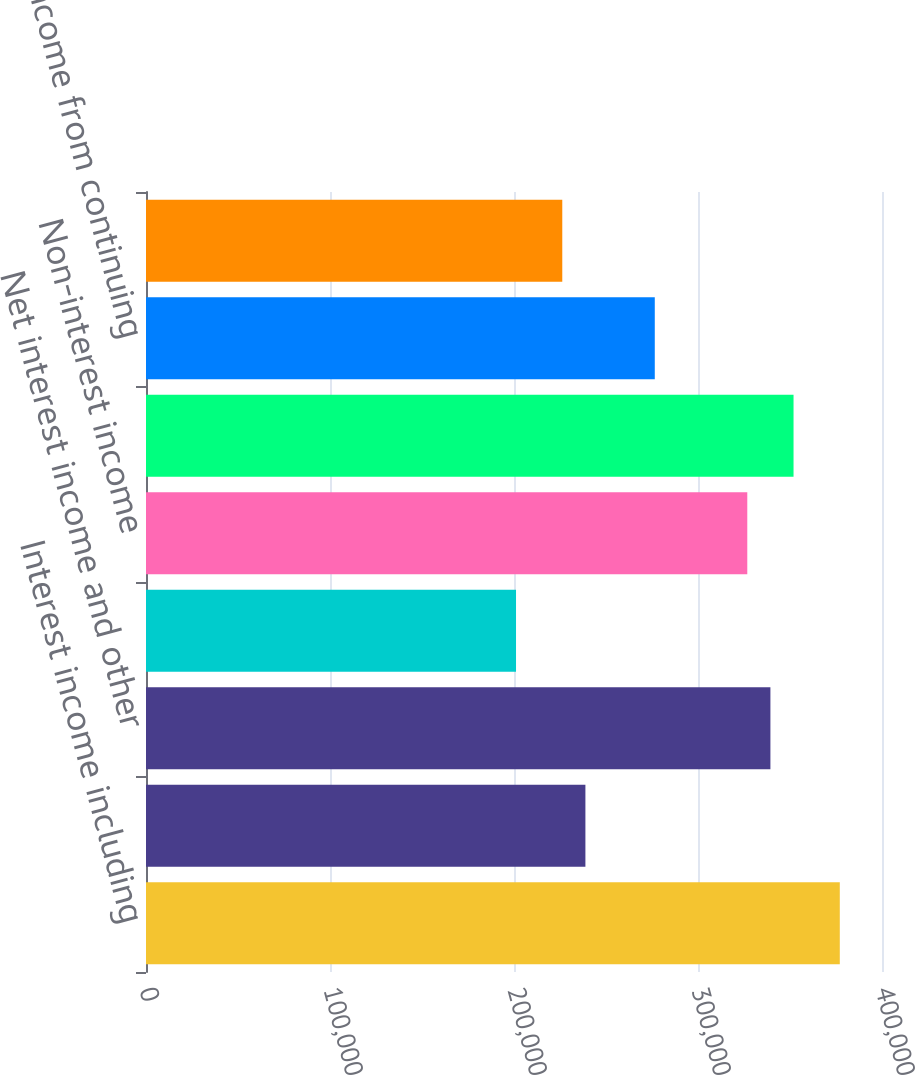Convert chart to OTSL. <chart><loc_0><loc_0><loc_500><loc_500><bar_chart><fcel>Interest income including<fcel>Interest expense and<fcel>Net interest income and other<fcel>Provision for loan losses<fcel>Non-interest income<fcel>Non-interest expense<fcel>Income from continuing<fcel>Income tax expense<nl><fcel>377061<fcel>238806<fcel>339355<fcel>201100<fcel>326787<fcel>351924<fcel>276512<fcel>226237<nl></chart> 